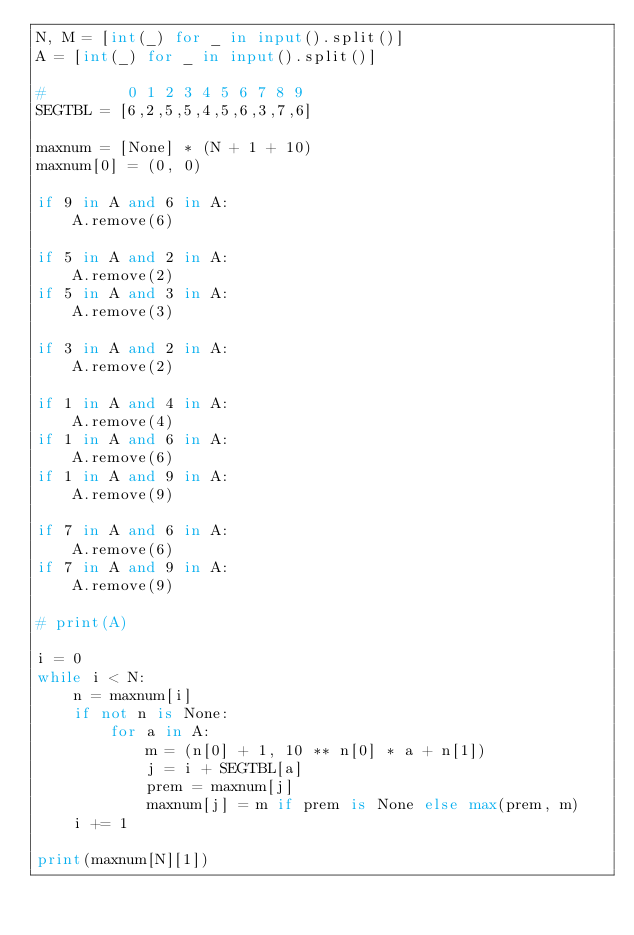<code> <loc_0><loc_0><loc_500><loc_500><_Python_>N, M = [int(_) for _ in input().split()]
A = [int(_) for _ in input().split()]

#         0 1 2 3 4 5 6 7 8 9
SEGTBL = [6,2,5,5,4,5,6,3,7,6]

maxnum = [None] * (N + 1 + 10)
maxnum[0] = (0, 0)

if 9 in A and 6 in A:
    A.remove(6)

if 5 in A and 2 in A:
    A.remove(2)
if 5 in A and 3 in A:
    A.remove(3)

if 3 in A and 2 in A:
    A.remove(2)

if 1 in A and 4 in A:
    A.remove(4)
if 1 in A and 6 in A:
    A.remove(6)
if 1 in A and 9 in A:
    A.remove(9)

if 7 in A and 6 in A:
    A.remove(6)
if 7 in A and 9 in A:
    A.remove(9)

# print(A)

i = 0
while i < N:
    n = maxnum[i]
    if not n is None:
        for a in A:
            m = (n[0] + 1, 10 ** n[0] * a + n[1])
            j = i + SEGTBL[a]
            prem = maxnum[j]
            maxnum[j] = m if prem is None else max(prem, m)
    i += 1

print(maxnum[N][1])
</code> 